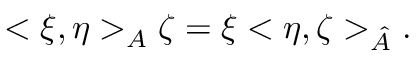<formula> <loc_0><loc_0><loc_500><loc_500>< \xi , \eta > _ { A } \zeta = \xi < \eta , \zeta > _ { \hat { A } } .</formula> 